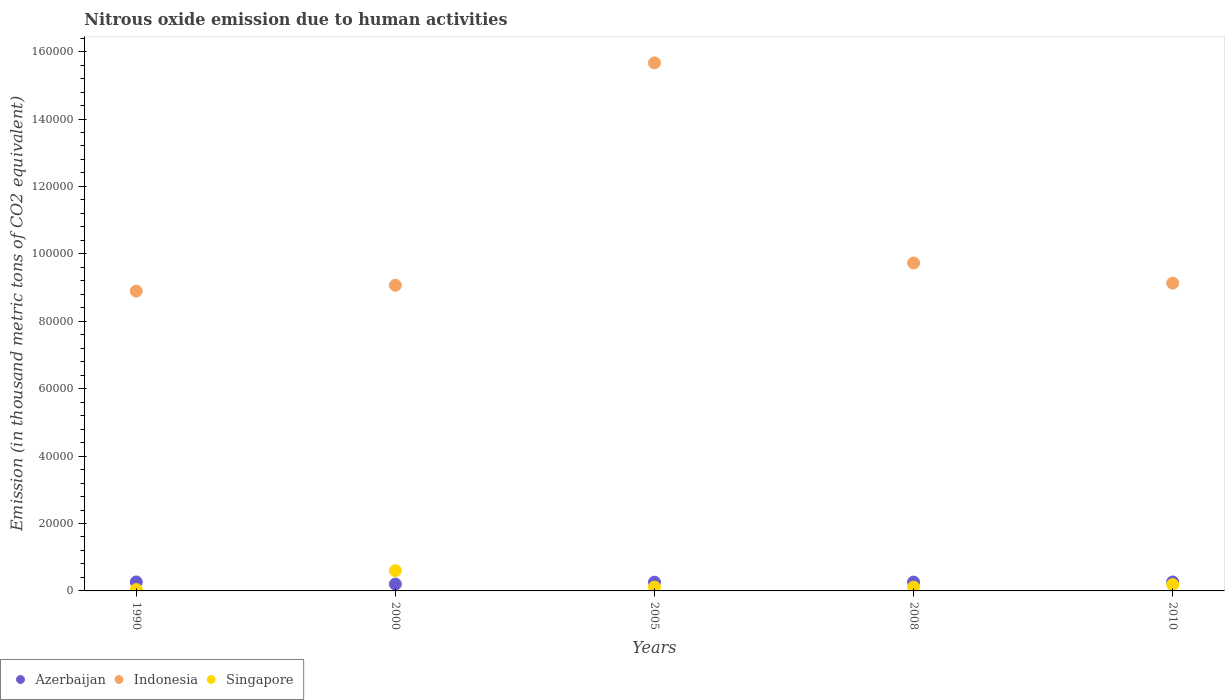How many different coloured dotlines are there?
Ensure brevity in your answer.  3. What is the amount of nitrous oxide emitted in Azerbaijan in 1990?
Provide a short and direct response. 2665.8. Across all years, what is the maximum amount of nitrous oxide emitted in Azerbaijan?
Offer a very short reply. 2665.8. Across all years, what is the minimum amount of nitrous oxide emitted in Azerbaijan?
Keep it short and to the point. 2031.7. In which year was the amount of nitrous oxide emitted in Azerbaijan maximum?
Offer a very short reply. 1990. What is the total amount of nitrous oxide emitted in Indonesia in the graph?
Your answer should be compact. 5.25e+05. What is the difference between the amount of nitrous oxide emitted in Azerbaijan in 1990 and that in 2008?
Your answer should be compact. 43.4. What is the difference between the amount of nitrous oxide emitted in Singapore in 2000 and the amount of nitrous oxide emitted in Azerbaijan in 2005?
Offer a very short reply. 3407.1. What is the average amount of nitrous oxide emitted in Azerbaijan per year?
Make the answer very short. 2513.22. In the year 2010, what is the difference between the amount of nitrous oxide emitted in Azerbaijan and amount of nitrous oxide emitted in Singapore?
Make the answer very short. 775.5. What is the ratio of the amount of nitrous oxide emitted in Azerbaijan in 1990 to that in 2005?
Give a very brief answer. 1.03. Is the amount of nitrous oxide emitted in Azerbaijan in 1990 less than that in 2005?
Your answer should be compact. No. Is the difference between the amount of nitrous oxide emitted in Azerbaijan in 2000 and 2005 greater than the difference between the amount of nitrous oxide emitted in Singapore in 2000 and 2005?
Provide a succinct answer. No. What is the difference between the highest and the second highest amount of nitrous oxide emitted in Indonesia?
Your response must be concise. 5.94e+04. What is the difference between the highest and the lowest amount of nitrous oxide emitted in Indonesia?
Ensure brevity in your answer.  6.77e+04. Is it the case that in every year, the sum of the amount of nitrous oxide emitted in Indonesia and amount of nitrous oxide emitted in Azerbaijan  is greater than the amount of nitrous oxide emitted in Singapore?
Provide a succinct answer. Yes. How many dotlines are there?
Your answer should be very brief. 3. How many years are there in the graph?
Offer a terse response. 5. How many legend labels are there?
Your answer should be compact. 3. What is the title of the graph?
Offer a very short reply. Nitrous oxide emission due to human activities. Does "Israel" appear as one of the legend labels in the graph?
Offer a terse response. No. What is the label or title of the X-axis?
Your answer should be compact. Years. What is the label or title of the Y-axis?
Offer a terse response. Emission (in thousand metric tons of CO2 equivalent). What is the Emission (in thousand metric tons of CO2 equivalent) in Azerbaijan in 1990?
Your answer should be compact. 2665.8. What is the Emission (in thousand metric tons of CO2 equivalent) in Indonesia in 1990?
Provide a short and direct response. 8.89e+04. What is the Emission (in thousand metric tons of CO2 equivalent) in Singapore in 1990?
Ensure brevity in your answer.  403.4. What is the Emission (in thousand metric tons of CO2 equivalent) of Azerbaijan in 2000?
Make the answer very short. 2031.7. What is the Emission (in thousand metric tons of CO2 equivalent) in Indonesia in 2000?
Your answer should be compact. 9.07e+04. What is the Emission (in thousand metric tons of CO2 equivalent) of Singapore in 2000?
Keep it short and to the point. 6006.7. What is the Emission (in thousand metric tons of CO2 equivalent) of Azerbaijan in 2005?
Your response must be concise. 2599.6. What is the Emission (in thousand metric tons of CO2 equivalent) of Indonesia in 2005?
Your answer should be compact. 1.57e+05. What is the Emission (in thousand metric tons of CO2 equivalent) of Singapore in 2005?
Your answer should be very brief. 1127.5. What is the Emission (in thousand metric tons of CO2 equivalent) in Azerbaijan in 2008?
Keep it short and to the point. 2622.4. What is the Emission (in thousand metric tons of CO2 equivalent) of Indonesia in 2008?
Provide a succinct answer. 9.73e+04. What is the Emission (in thousand metric tons of CO2 equivalent) in Singapore in 2008?
Offer a terse response. 1113.5. What is the Emission (in thousand metric tons of CO2 equivalent) in Azerbaijan in 2010?
Offer a very short reply. 2646.6. What is the Emission (in thousand metric tons of CO2 equivalent) of Indonesia in 2010?
Offer a very short reply. 9.13e+04. What is the Emission (in thousand metric tons of CO2 equivalent) of Singapore in 2010?
Offer a terse response. 1871.1. Across all years, what is the maximum Emission (in thousand metric tons of CO2 equivalent) in Azerbaijan?
Provide a short and direct response. 2665.8. Across all years, what is the maximum Emission (in thousand metric tons of CO2 equivalent) in Indonesia?
Your answer should be compact. 1.57e+05. Across all years, what is the maximum Emission (in thousand metric tons of CO2 equivalent) in Singapore?
Offer a terse response. 6006.7. Across all years, what is the minimum Emission (in thousand metric tons of CO2 equivalent) in Azerbaijan?
Ensure brevity in your answer.  2031.7. Across all years, what is the minimum Emission (in thousand metric tons of CO2 equivalent) in Indonesia?
Your answer should be very brief. 8.89e+04. Across all years, what is the minimum Emission (in thousand metric tons of CO2 equivalent) of Singapore?
Offer a terse response. 403.4. What is the total Emission (in thousand metric tons of CO2 equivalent) in Azerbaijan in the graph?
Your answer should be compact. 1.26e+04. What is the total Emission (in thousand metric tons of CO2 equivalent) in Indonesia in the graph?
Give a very brief answer. 5.25e+05. What is the total Emission (in thousand metric tons of CO2 equivalent) of Singapore in the graph?
Offer a very short reply. 1.05e+04. What is the difference between the Emission (in thousand metric tons of CO2 equivalent) of Azerbaijan in 1990 and that in 2000?
Ensure brevity in your answer.  634.1. What is the difference between the Emission (in thousand metric tons of CO2 equivalent) of Indonesia in 1990 and that in 2000?
Provide a short and direct response. -1727.1. What is the difference between the Emission (in thousand metric tons of CO2 equivalent) of Singapore in 1990 and that in 2000?
Your answer should be compact. -5603.3. What is the difference between the Emission (in thousand metric tons of CO2 equivalent) in Azerbaijan in 1990 and that in 2005?
Provide a short and direct response. 66.2. What is the difference between the Emission (in thousand metric tons of CO2 equivalent) in Indonesia in 1990 and that in 2005?
Ensure brevity in your answer.  -6.77e+04. What is the difference between the Emission (in thousand metric tons of CO2 equivalent) of Singapore in 1990 and that in 2005?
Offer a very short reply. -724.1. What is the difference between the Emission (in thousand metric tons of CO2 equivalent) in Azerbaijan in 1990 and that in 2008?
Provide a succinct answer. 43.4. What is the difference between the Emission (in thousand metric tons of CO2 equivalent) of Indonesia in 1990 and that in 2008?
Your response must be concise. -8337.4. What is the difference between the Emission (in thousand metric tons of CO2 equivalent) in Singapore in 1990 and that in 2008?
Your response must be concise. -710.1. What is the difference between the Emission (in thousand metric tons of CO2 equivalent) of Indonesia in 1990 and that in 2010?
Offer a very short reply. -2363.1. What is the difference between the Emission (in thousand metric tons of CO2 equivalent) in Singapore in 1990 and that in 2010?
Offer a very short reply. -1467.7. What is the difference between the Emission (in thousand metric tons of CO2 equivalent) of Azerbaijan in 2000 and that in 2005?
Provide a succinct answer. -567.9. What is the difference between the Emission (in thousand metric tons of CO2 equivalent) in Indonesia in 2000 and that in 2005?
Offer a very short reply. -6.60e+04. What is the difference between the Emission (in thousand metric tons of CO2 equivalent) in Singapore in 2000 and that in 2005?
Provide a succinct answer. 4879.2. What is the difference between the Emission (in thousand metric tons of CO2 equivalent) of Azerbaijan in 2000 and that in 2008?
Your response must be concise. -590.7. What is the difference between the Emission (in thousand metric tons of CO2 equivalent) of Indonesia in 2000 and that in 2008?
Make the answer very short. -6610.3. What is the difference between the Emission (in thousand metric tons of CO2 equivalent) of Singapore in 2000 and that in 2008?
Keep it short and to the point. 4893.2. What is the difference between the Emission (in thousand metric tons of CO2 equivalent) in Azerbaijan in 2000 and that in 2010?
Offer a very short reply. -614.9. What is the difference between the Emission (in thousand metric tons of CO2 equivalent) in Indonesia in 2000 and that in 2010?
Give a very brief answer. -636. What is the difference between the Emission (in thousand metric tons of CO2 equivalent) in Singapore in 2000 and that in 2010?
Offer a terse response. 4135.6. What is the difference between the Emission (in thousand metric tons of CO2 equivalent) in Azerbaijan in 2005 and that in 2008?
Your answer should be very brief. -22.8. What is the difference between the Emission (in thousand metric tons of CO2 equivalent) of Indonesia in 2005 and that in 2008?
Give a very brief answer. 5.94e+04. What is the difference between the Emission (in thousand metric tons of CO2 equivalent) of Azerbaijan in 2005 and that in 2010?
Your response must be concise. -47. What is the difference between the Emission (in thousand metric tons of CO2 equivalent) in Indonesia in 2005 and that in 2010?
Keep it short and to the point. 6.53e+04. What is the difference between the Emission (in thousand metric tons of CO2 equivalent) in Singapore in 2005 and that in 2010?
Provide a short and direct response. -743.6. What is the difference between the Emission (in thousand metric tons of CO2 equivalent) in Azerbaijan in 2008 and that in 2010?
Give a very brief answer. -24.2. What is the difference between the Emission (in thousand metric tons of CO2 equivalent) in Indonesia in 2008 and that in 2010?
Your answer should be compact. 5974.3. What is the difference between the Emission (in thousand metric tons of CO2 equivalent) of Singapore in 2008 and that in 2010?
Ensure brevity in your answer.  -757.6. What is the difference between the Emission (in thousand metric tons of CO2 equivalent) in Azerbaijan in 1990 and the Emission (in thousand metric tons of CO2 equivalent) in Indonesia in 2000?
Provide a succinct answer. -8.80e+04. What is the difference between the Emission (in thousand metric tons of CO2 equivalent) of Azerbaijan in 1990 and the Emission (in thousand metric tons of CO2 equivalent) of Singapore in 2000?
Your answer should be very brief. -3340.9. What is the difference between the Emission (in thousand metric tons of CO2 equivalent) in Indonesia in 1990 and the Emission (in thousand metric tons of CO2 equivalent) in Singapore in 2000?
Ensure brevity in your answer.  8.29e+04. What is the difference between the Emission (in thousand metric tons of CO2 equivalent) in Azerbaijan in 1990 and the Emission (in thousand metric tons of CO2 equivalent) in Indonesia in 2005?
Offer a terse response. -1.54e+05. What is the difference between the Emission (in thousand metric tons of CO2 equivalent) in Azerbaijan in 1990 and the Emission (in thousand metric tons of CO2 equivalent) in Singapore in 2005?
Offer a very short reply. 1538.3. What is the difference between the Emission (in thousand metric tons of CO2 equivalent) of Indonesia in 1990 and the Emission (in thousand metric tons of CO2 equivalent) of Singapore in 2005?
Keep it short and to the point. 8.78e+04. What is the difference between the Emission (in thousand metric tons of CO2 equivalent) in Azerbaijan in 1990 and the Emission (in thousand metric tons of CO2 equivalent) in Indonesia in 2008?
Keep it short and to the point. -9.46e+04. What is the difference between the Emission (in thousand metric tons of CO2 equivalent) in Azerbaijan in 1990 and the Emission (in thousand metric tons of CO2 equivalent) in Singapore in 2008?
Your response must be concise. 1552.3. What is the difference between the Emission (in thousand metric tons of CO2 equivalent) in Indonesia in 1990 and the Emission (in thousand metric tons of CO2 equivalent) in Singapore in 2008?
Ensure brevity in your answer.  8.78e+04. What is the difference between the Emission (in thousand metric tons of CO2 equivalent) in Azerbaijan in 1990 and the Emission (in thousand metric tons of CO2 equivalent) in Indonesia in 2010?
Provide a succinct answer. -8.86e+04. What is the difference between the Emission (in thousand metric tons of CO2 equivalent) in Azerbaijan in 1990 and the Emission (in thousand metric tons of CO2 equivalent) in Singapore in 2010?
Keep it short and to the point. 794.7. What is the difference between the Emission (in thousand metric tons of CO2 equivalent) in Indonesia in 1990 and the Emission (in thousand metric tons of CO2 equivalent) in Singapore in 2010?
Your answer should be very brief. 8.71e+04. What is the difference between the Emission (in thousand metric tons of CO2 equivalent) of Azerbaijan in 2000 and the Emission (in thousand metric tons of CO2 equivalent) of Indonesia in 2005?
Offer a very short reply. -1.55e+05. What is the difference between the Emission (in thousand metric tons of CO2 equivalent) in Azerbaijan in 2000 and the Emission (in thousand metric tons of CO2 equivalent) in Singapore in 2005?
Your answer should be very brief. 904.2. What is the difference between the Emission (in thousand metric tons of CO2 equivalent) of Indonesia in 2000 and the Emission (in thousand metric tons of CO2 equivalent) of Singapore in 2005?
Your answer should be compact. 8.95e+04. What is the difference between the Emission (in thousand metric tons of CO2 equivalent) of Azerbaijan in 2000 and the Emission (in thousand metric tons of CO2 equivalent) of Indonesia in 2008?
Provide a succinct answer. -9.53e+04. What is the difference between the Emission (in thousand metric tons of CO2 equivalent) in Azerbaijan in 2000 and the Emission (in thousand metric tons of CO2 equivalent) in Singapore in 2008?
Your answer should be very brief. 918.2. What is the difference between the Emission (in thousand metric tons of CO2 equivalent) in Indonesia in 2000 and the Emission (in thousand metric tons of CO2 equivalent) in Singapore in 2008?
Give a very brief answer. 8.96e+04. What is the difference between the Emission (in thousand metric tons of CO2 equivalent) of Azerbaijan in 2000 and the Emission (in thousand metric tons of CO2 equivalent) of Indonesia in 2010?
Your answer should be very brief. -8.93e+04. What is the difference between the Emission (in thousand metric tons of CO2 equivalent) of Azerbaijan in 2000 and the Emission (in thousand metric tons of CO2 equivalent) of Singapore in 2010?
Offer a terse response. 160.6. What is the difference between the Emission (in thousand metric tons of CO2 equivalent) of Indonesia in 2000 and the Emission (in thousand metric tons of CO2 equivalent) of Singapore in 2010?
Ensure brevity in your answer.  8.88e+04. What is the difference between the Emission (in thousand metric tons of CO2 equivalent) of Azerbaijan in 2005 and the Emission (in thousand metric tons of CO2 equivalent) of Indonesia in 2008?
Your answer should be very brief. -9.47e+04. What is the difference between the Emission (in thousand metric tons of CO2 equivalent) of Azerbaijan in 2005 and the Emission (in thousand metric tons of CO2 equivalent) of Singapore in 2008?
Your response must be concise. 1486.1. What is the difference between the Emission (in thousand metric tons of CO2 equivalent) in Indonesia in 2005 and the Emission (in thousand metric tons of CO2 equivalent) in Singapore in 2008?
Ensure brevity in your answer.  1.56e+05. What is the difference between the Emission (in thousand metric tons of CO2 equivalent) in Azerbaijan in 2005 and the Emission (in thousand metric tons of CO2 equivalent) in Indonesia in 2010?
Your answer should be compact. -8.87e+04. What is the difference between the Emission (in thousand metric tons of CO2 equivalent) of Azerbaijan in 2005 and the Emission (in thousand metric tons of CO2 equivalent) of Singapore in 2010?
Make the answer very short. 728.5. What is the difference between the Emission (in thousand metric tons of CO2 equivalent) in Indonesia in 2005 and the Emission (in thousand metric tons of CO2 equivalent) in Singapore in 2010?
Your response must be concise. 1.55e+05. What is the difference between the Emission (in thousand metric tons of CO2 equivalent) of Azerbaijan in 2008 and the Emission (in thousand metric tons of CO2 equivalent) of Indonesia in 2010?
Give a very brief answer. -8.87e+04. What is the difference between the Emission (in thousand metric tons of CO2 equivalent) in Azerbaijan in 2008 and the Emission (in thousand metric tons of CO2 equivalent) in Singapore in 2010?
Provide a succinct answer. 751.3. What is the difference between the Emission (in thousand metric tons of CO2 equivalent) of Indonesia in 2008 and the Emission (in thousand metric tons of CO2 equivalent) of Singapore in 2010?
Give a very brief answer. 9.54e+04. What is the average Emission (in thousand metric tons of CO2 equivalent) of Azerbaijan per year?
Ensure brevity in your answer.  2513.22. What is the average Emission (in thousand metric tons of CO2 equivalent) of Indonesia per year?
Keep it short and to the point. 1.05e+05. What is the average Emission (in thousand metric tons of CO2 equivalent) in Singapore per year?
Give a very brief answer. 2104.44. In the year 1990, what is the difference between the Emission (in thousand metric tons of CO2 equivalent) of Azerbaijan and Emission (in thousand metric tons of CO2 equivalent) of Indonesia?
Your response must be concise. -8.63e+04. In the year 1990, what is the difference between the Emission (in thousand metric tons of CO2 equivalent) in Azerbaijan and Emission (in thousand metric tons of CO2 equivalent) in Singapore?
Provide a succinct answer. 2262.4. In the year 1990, what is the difference between the Emission (in thousand metric tons of CO2 equivalent) of Indonesia and Emission (in thousand metric tons of CO2 equivalent) of Singapore?
Give a very brief answer. 8.85e+04. In the year 2000, what is the difference between the Emission (in thousand metric tons of CO2 equivalent) in Azerbaijan and Emission (in thousand metric tons of CO2 equivalent) in Indonesia?
Provide a succinct answer. -8.86e+04. In the year 2000, what is the difference between the Emission (in thousand metric tons of CO2 equivalent) in Azerbaijan and Emission (in thousand metric tons of CO2 equivalent) in Singapore?
Make the answer very short. -3975. In the year 2000, what is the difference between the Emission (in thousand metric tons of CO2 equivalent) in Indonesia and Emission (in thousand metric tons of CO2 equivalent) in Singapore?
Your response must be concise. 8.47e+04. In the year 2005, what is the difference between the Emission (in thousand metric tons of CO2 equivalent) in Azerbaijan and Emission (in thousand metric tons of CO2 equivalent) in Indonesia?
Give a very brief answer. -1.54e+05. In the year 2005, what is the difference between the Emission (in thousand metric tons of CO2 equivalent) of Azerbaijan and Emission (in thousand metric tons of CO2 equivalent) of Singapore?
Provide a short and direct response. 1472.1. In the year 2005, what is the difference between the Emission (in thousand metric tons of CO2 equivalent) in Indonesia and Emission (in thousand metric tons of CO2 equivalent) in Singapore?
Ensure brevity in your answer.  1.56e+05. In the year 2008, what is the difference between the Emission (in thousand metric tons of CO2 equivalent) in Azerbaijan and Emission (in thousand metric tons of CO2 equivalent) in Indonesia?
Ensure brevity in your answer.  -9.47e+04. In the year 2008, what is the difference between the Emission (in thousand metric tons of CO2 equivalent) in Azerbaijan and Emission (in thousand metric tons of CO2 equivalent) in Singapore?
Offer a terse response. 1508.9. In the year 2008, what is the difference between the Emission (in thousand metric tons of CO2 equivalent) of Indonesia and Emission (in thousand metric tons of CO2 equivalent) of Singapore?
Offer a terse response. 9.62e+04. In the year 2010, what is the difference between the Emission (in thousand metric tons of CO2 equivalent) in Azerbaijan and Emission (in thousand metric tons of CO2 equivalent) in Indonesia?
Your response must be concise. -8.87e+04. In the year 2010, what is the difference between the Emission (in thousand metric tons of CO2 equivalent) in Azerbaijan and Emission (in thousand metric tons of CO2 equivalent) in Singapore?
Keep it short and to the point. 775.5. In the year 2010, what is the difference between the Emission (in thousand metric tons of CO2 equivalent) of Indonesia and Emission (in thousand metric tons of CO2 equivalent) of Singapore?
Provide a short and direct response. 8.94e+04. What is the ratio of the Emission (in thousand metric tons of CO2 equivalent) of Azerbaijan in 1990 to that in 2000?
Your answer should be very brief. 1.31. What is the ratio of the Emission (in thousand metric tons of CO2 equivalent) of Singapore in 1990 to that in 2000?
Your answer should be compact. 0.07. What is the ratio of the Emission (in thousand metric tons of CO2 equivalent) in Azerbaijan in 1990 to that in 2005?
Make the answer very short. 1.03. What is the ratio of the Emission (in thousand metric tons of CO2 equivalent) of Indonesia in 1990 to that in 2005?
Offer a very short reply. 0.57. What is the ratio of the Emission (in thousand metric tons of CO2 equivalent) of Singapore in 1990 to that in 2005?
Keep it short and to the point. 0.36. What is the ratio of the Emission (in thousand metric tons of CO2 equivalent) of Azerbaijan in 1990 to that in 2008?
Your answer should be very brief. 1.02. What is the ratio of the Emission (in thousand metric tons of CO2 equivalent) of Indonesia in 1990 to that in 2008?
Your answer should be compact. 0.91. What is the ratio of the Emission (in thousand metric tons of CO2 equivalent) in Singapore in 1990 to that in 2008?
Your answer should be compact. 0.36. What is the ratio of the Emission (in thousand metric tons of CO2 equivalent) in Azerbaijan in 1990 to that in 2010?
Provide a short and direct response. 1.01. What is the ratio of the Emission (in thousand metric tons of CO2 equivalent) in Indonesia in 1990 to that in 2010?
Keep it short and to the point. 0.97. What is the ratio of the Emission (in thousand metric tons of CO2 equivalent) of Singapore in 1990 to that in 2010?
Ensure brevity in your answer.  0.22. What is the ratio of the Emission (in thousand metric tons of CO2 equivalent) of Azerbaijan in 2000 to that in 2005?
Provide a succinct answer. 0.78. What is the ratio of the Emission (in thousand metric tons of CO2 equivalent) of Indonesia in 2000 to that in 2005?
Your answer should be very brief. 0.58. What is the ratio of the Emission (in thousand metric tons of CO2 equivalent) in Singapore in 2000 to that in 2005?
Give a very brief answer. 5.33. What is the ratio of the Emission (in thousand metric tons of CO2 equivalent) of Azerbaijan in 2000 to that in 2008?
Your answer should be compact. 0.77. What is the ratio of the Emission (in thousand metric tons of CO2 equivalent) in Indonesia in 2000 to that in 2008?
Ensure brevity in your answer.  0.93. What is the ratio of the Emission (in thousand metric tons of CO2 equivalent) of Singapore in 2000 to that in 2008?
Provide a short and direct response. 5.39. What is the ratio of the Emission (in thousand metric tons of CO2 equivalent) in Azerbaijan in 2000 to that in 2010?
Offer a terse response. 0.77. What is the ratio of the Emission (in thousand metric tons of CO2 equivalent) of Singapore in 2000 to that in 2010?
Ensure brevity in your answer.  3.21. What is the ratio of the Emission (in thousand metric tons of CO2 equivalent) in Indonesia in 2005 to that in 2008?
Your response must be concise. 1.61. What is the ratio of the Emission (in thousand metric tons of CO2 equivalent) in Singapore in 2005 to that in 2008?
Offer a very short reply. 1.01. What is the ratio of the Emission (in thousand metric tons of CO2 equivalent) in Azerbaijan in 2005 to that in 2010?
Provide a succinct answer. 0.98. What is the ratio of the Emission (in thousand metric tons of CO2 equivalent) in Indonesia in 2005 to that in 2010?
Offer a very short reply. 1.72. What is the ratio of the Emission (in thousand metric tons of CO2 equivalent) in Singapore in 2005 to that in 2010?
Offer a terse response. 0.6. What is the ratio of the Emission (in thousand metric tons of CO2 equivalent) of Azerbaijan in 2008 to that in 2010?
Offer a very short reply. 0.99. What is the ratio of the Emission (in thousand metric tons of CO2 equivalent) in Indonesia in 2008 to that in 2010?
Offer a terse response. 1.07. What is the ratio of the Emission (in thousand metric tons of CO2 equivalent) in Singapore in 2008 to that in 2010?
Keep it short and to the point. 0.6. What is the difference between the highest and the second highest Emission (in thousand metric tons of CO2 equivalent) in Indonesia?
Offer a very short reply. 5.94e+04. What is the difference between the highest and the second highest Emission (in thousand metric tons of CO2 equivalent) of Singapore?
Give a very brief answer. 4135.6. What is the difference between the highest and the lowest Emission (in thousand metric tons of CO2 equivalent) in Azerbaijan?
Keep it short and to the point. 634.1. What is the difference between the highest and the lowest Emission (in thousand metric tons of CO2 equivalent) of Indonesia?
Ensure brevity in your answer.  6.77e+04. What is the difference between the highest and the lowest Emission (in thousand metric tons of CO2 equivalent) of Singapore?
Your answer should be very brief. 5603.3. 